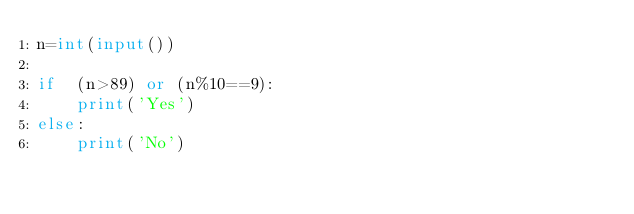<code> <loc_0><loc_0><loc_500><loc_500><_Python_>n=int(input())

if  (n>89) or (n%10==9):
    print('Yes')
else:
    print('No')</code> 